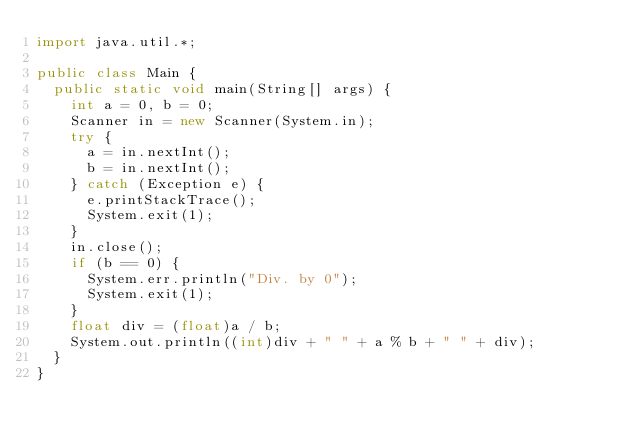<code> <loc_0><loc_0><loc_500><loc_500><_Java_>import java.util.*;

public class Main {
	public static void main(String[] args) {
		int a = 0, b = 0;
		Scanner in = new Scanner(System.in);
		try {
			a = in.nextInt();
			b = in.nextInt();
		} catch (Exception e) {
			e.printStackTrace();
			System.exit(1);
		}
		in.close();
		if (b == 0) {
			System.err.println("Div. by 0");
			System.exit(1);
		}
		float div = (float)a / b;
		System.out.println((int)div + " " + a % b + " " + div);
	}
}</code> 